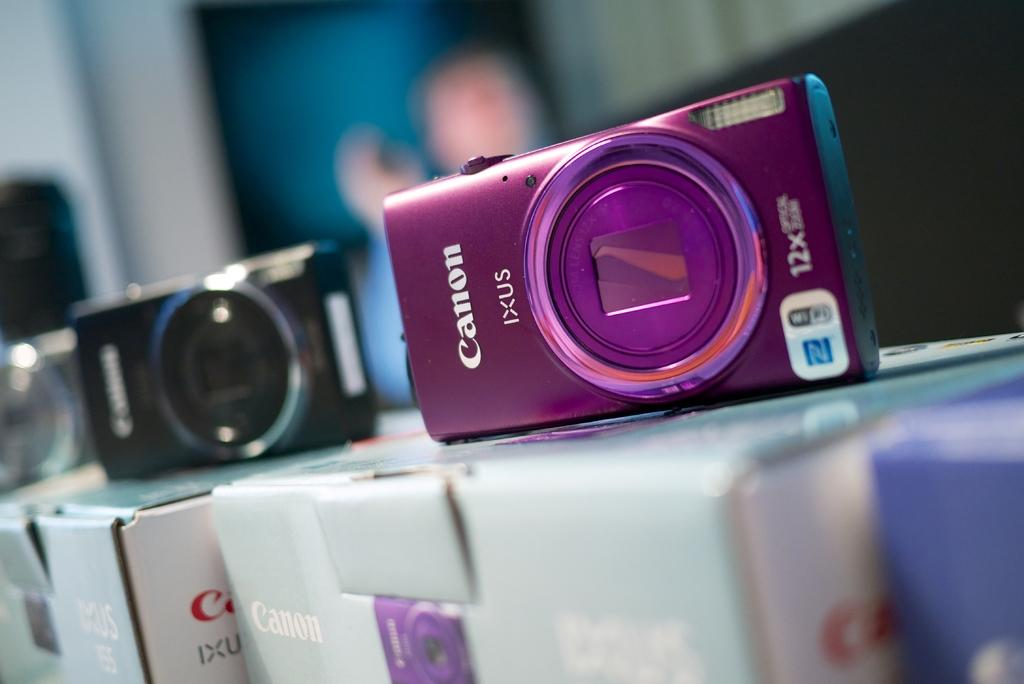Provide a one-sentence caption for the provided image. Several Canon digital cameras sit on display on top of their boxes. 